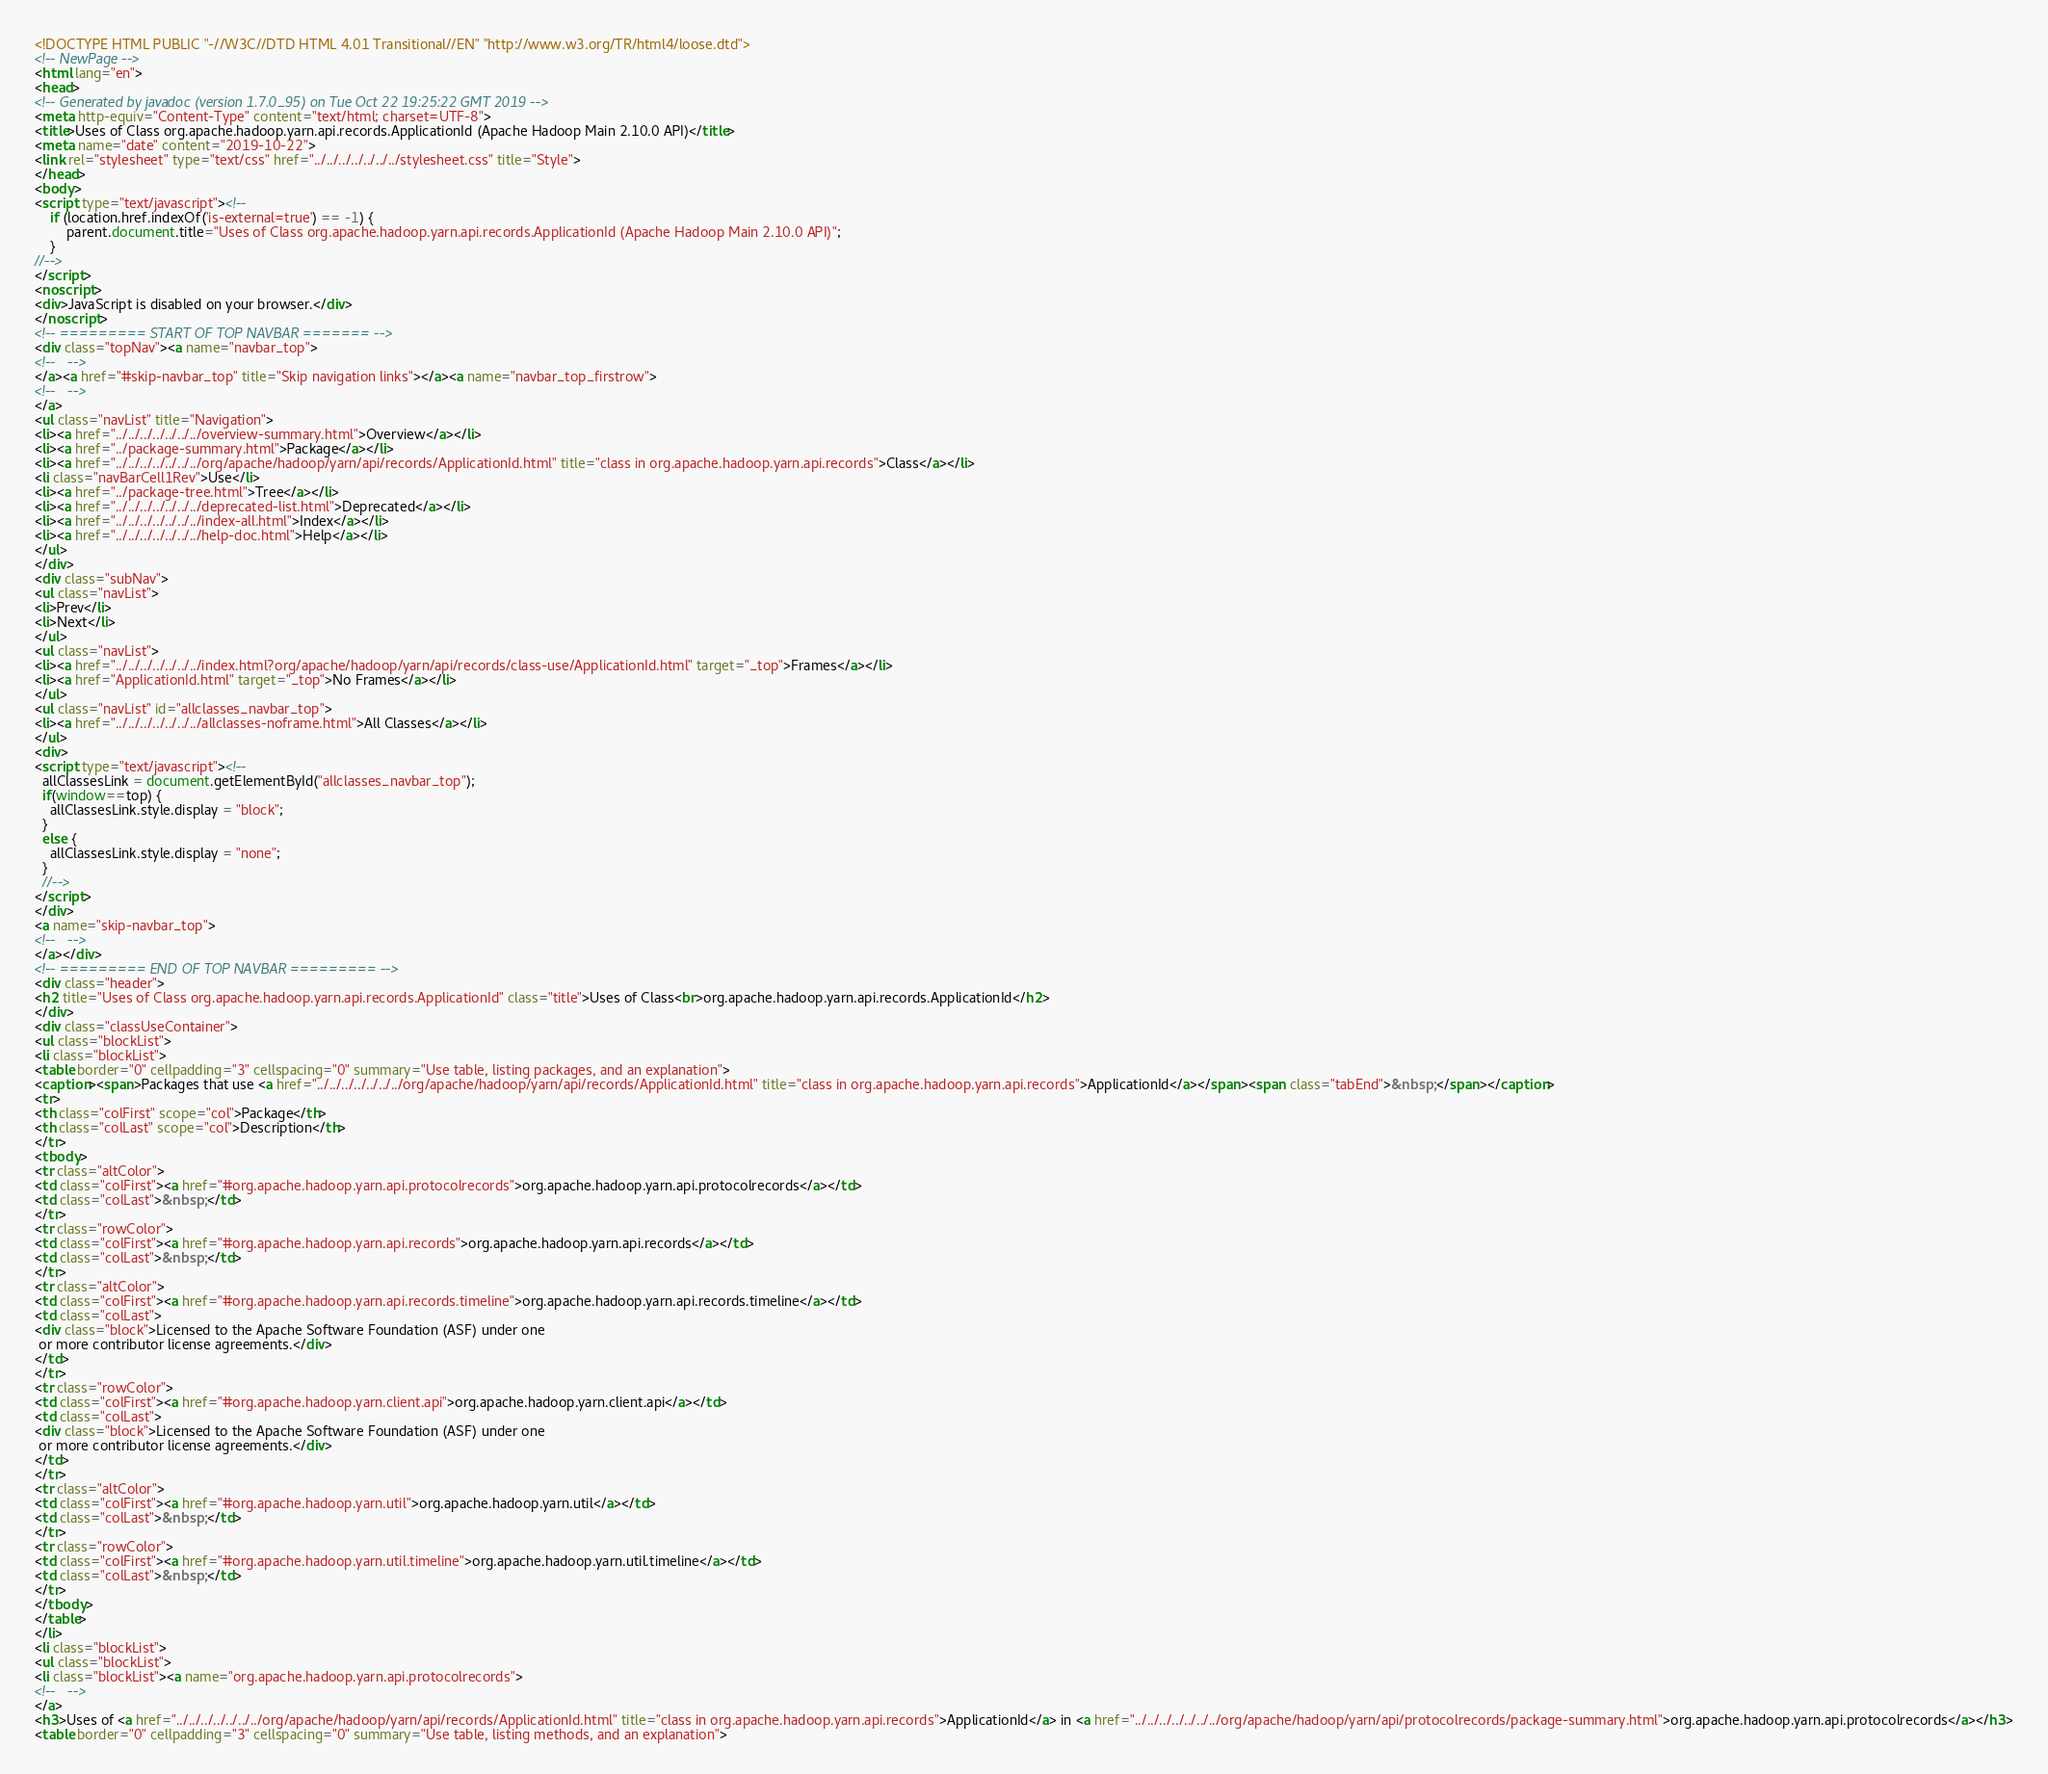Convert code to text. <code><loc_0><loc_0><loc_500><loc_500><_HTML_><!DOCTYPE HTML PUBLIC "-//W3C//DTD HTML 4.01 Transitional//EN" "http://www.w3.org/TR/html4/loose.dtd">
<!-- NewPage -->
<html lang="en">
<head>
<!-- Generated by javadoc (version 1.7.0_95) on Tue Oct 22 19:25:22 GMT 2019 -->
<meta http-equiv="Content-Type" content="text/html; charset=UTF-8">
<title>Uses of Class org.apache.hadoop.yarn.api.records.ApplicationId (Apache Hadoop Main 2.10.0 API)</title>
<meta name="date" content="2019-10-22">
<link rel="stylesheet" type="text/css" href="../../../../../../../stylesheet.css" title="Style">
</head>
<body>
<script type="text/javascript"><!--
    if (location.href.indexOf('is-external=true') == -1) {
        parent.document.title="Uses of Class org.apache.hadoop.yarn.api.records.ApplicationId (Apache Hadoop Main 2.10.0 API)";
    }
//-->
</script>
<noscript>
<div>JavaScript is disabled on your browser.</div>
</noscript>
<!-- ========= START OF TOP NAVBAR ======= -->
<div class="topNav"><a name="navbar_top">
<!--   -->
</a><a href="#skip-navbar_top" title="Skip navigation links"></a><a name="navbar_top_firstrow">
<!--   -->
</a>
<ul class="navList" title="Navigation">
<li><a href="../../../../../../../overview-summary.html">Overview</a></li>
<li><a href="../package-summary.html">Package</a></li>
<li><a href="../../../../../../../org/apache/hadoop/yarn/api/records/ApplicationId.html" title="class in org.apache.hadoop.yarn.api.records">Class</a></li>
<li class="navBarCell1Rev">Use</li>
<li><a href="../package-tree.html">Tree</a></li>
<li><a href="../../../../../../../deprecated-list.html">Deprecated</a></li>
<li><a href="../../../../../../../index-all.html">Index</a></li>
<li><a href="../../../../../../../help-doc.html">Help</a></li>
</ul>
</div>
<div class="subNav">
<ul class="navList">
<li>Prev</li>
<li>Next</li>
</ul>
<ul class="navList">
<li><a href="../../../../../../../index.html?org/apache/hadoop/yarn/api/records/class-use/ApplicationId.html" target="_top">Frames</a></li>
<li><a href="ApplicationId.html" target="_top">No Frames</a></li>
</ul>
<ul class="navList" id="allclasses_navbar_top">
<li><a href="../../../../../../../allclasses-noframe.html">All Classes</a></li>
</ul>
<div>
<script type="text/javascript"><!--
  allClassesLink = document.getElementById("allclasses_navbar_top");
  if(window==top) {
    allClassesLink.style.display = "block";
  }
  else {
    allClassesLink.style.display = "none";
  }
  //-->
</script>
</div>
<a name="skip-navbar_top">
<!--   -->
</a></div>
<!-- ========= END OF TOP NAVBAR ========= -->
<div class="header">
<h2 title="Uses of Class org.apache.hadoop.yarn.api.records.ApplicationId" class="title">Uses of Class<br>org.apache.hadoop.yarn.api.records.ApplicationId</h2>
</div>
<div class="classUseContainer">
<ul class="blockList">
<li class="blockList">
<table border="0" cellpadding="3" cellspacing="0" summary="Use table, listing packages, and an explanation">
<caption><span>Packages that use <a href="../../../../../../../org/apache/hadoop/yarn/api/records/ApplicationId.html" title="class in org.apache.hadoop.yarn.api.records">ApplicationId</a></span><span class="tabEnd">&nbsp;</span></caption>
<tr>
<th class="colFirst" scope="col">Package</th>
<th class="colLast" scope="col">Description</th>
</tr>
<tbody>
<tr class="altColor">
<td class="colFirst"><a href="#org.apache.hadoop.yarn.api.protocolrecords">org.apache.hadoop.yarn.api.protocolrecords</a></td>
<td class="colLast">&nbsp;</td>
</tr>
<tr class="rowColor">
<td class="colFirst"><a href="#org.apache.hadoop.yarn.api.records">org.apache.hadoop.yarn.api.records</a></td>
<td class="colLast">&nbsp;</td>
</tr>
<tr class="altColor">
<td class="colFirst"><a href="#org.apache.hadoop.yarn.api.records.timeline">org.apache.hadoop.yarn.api.records.timeline</a></td>
<td class="colLast">
<div class="block">Licensed to the Apache Software Foundation (ASF) under one
 or more contributor license agreements.</div>
</td>
</tr>
<tr class="rowColor">
<td class="colFirst"><a href="#org.apache.hadoop.yarn.client.api">org.apache.hadoop.yarn.client.api</a></td>
<td class="colLast">
<div class="block">Licensed to the Apache Software Foundation (ASF) under one
 or more contributor license agreements.</div>
</td>
</tr>
<tr class="altColor">
<td class="colFirst"><a href="#org.apache.hadoop.yarn.util">org.apache.hadoop.yarn.util</a></td>
<td class="colLast">&nbsp;</td>
</tr>
<tr class="rowColor">
<td class="colFirst"><a href="#org.apache.hadoop.yarn.util.timeline">org.apache.hadoop.yarn.util.timeline</a></td>
<td class="colLast">&nbsp;</td>
</tr>
</tbody>
</table>
</li>
<li class="blockList">
<ul class="blockList">
<li class="blockList"><a name="org.apache.hadoop.yarn.api.protocolrecords">
<!--   -->
</a>
<h3>Uses of <a href="../../../../../../../org/apache/hadoop/yarn/api/records/ApplicationId.html" title="class in org.apache.hadoop.yarn.api.records">ApplicationId</a> in <a href="../../../../../../../org/apache/hadoop/yarn/api/protocolrecords/package-summary.html">org.apache.hadoop.yarn.api.protocolrecords</a></h3>
<table border="0" cellpadding="3" cellspacing="0" summary="Use table, listing methods, and an explanation"></code> 